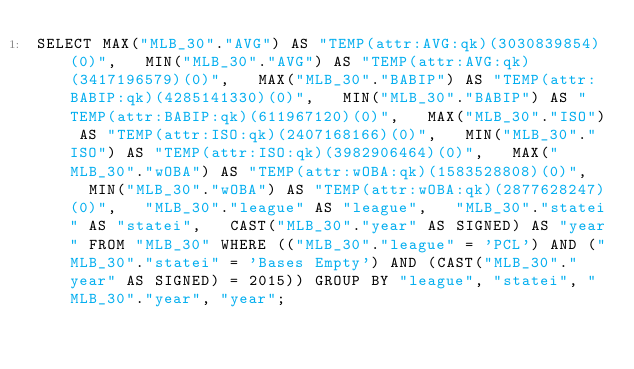<code> <loc_0><loc_0><loc_500><loc_500><_SQL_>SELECT MAX("MLB_30"."AVG") AS "TEMP(attr:AVG:qk)(3030839854)(0)",   MIN("MLB_30"."AVG") AS "TEMP(attr:AVG:qk)(3417196579)(0)",   MAX("MLB_30"."BABIP") AS "TEMP(attr:BABIP:qk)(4285141330)(0)",   MIN("MLB_30"."BABIP") AS "TEMP(attr:BABIP:qk)(611967120)(0)",   MAX("MLB_30"."ISO") AS "TEMP(attr:ISO:qk)(2407168166)(0)",   MIN("MLB_30"."ISO") AS "TEMP(attr:ISO:qk)(3982906464)(0)",   MAX("MLB_30"."wOBA") AS "TEMP(attr:wOBA:qk)(1583528808)(0)",   MIN("MLB_30"."wOBA") AS "TEMP(attr:wOBA:qk)(2877628247)(0)",   "MLB_30"."league" AS "league",   "MLB_30"."statei" AS "statei",   CAST("MLB_30"."year" AS SIGNED) AS "year" FROM "MLB_30" WHERE (("MLB_30"."league" = 'PCL') AND ("MLB_30"."statei" = 'Bases Empty') AND (CAST("MLB_30"."year" AS SIGNED) = 2015)) GROUP BY "league", "statei", "MLB_30"."year", "year";</code> 